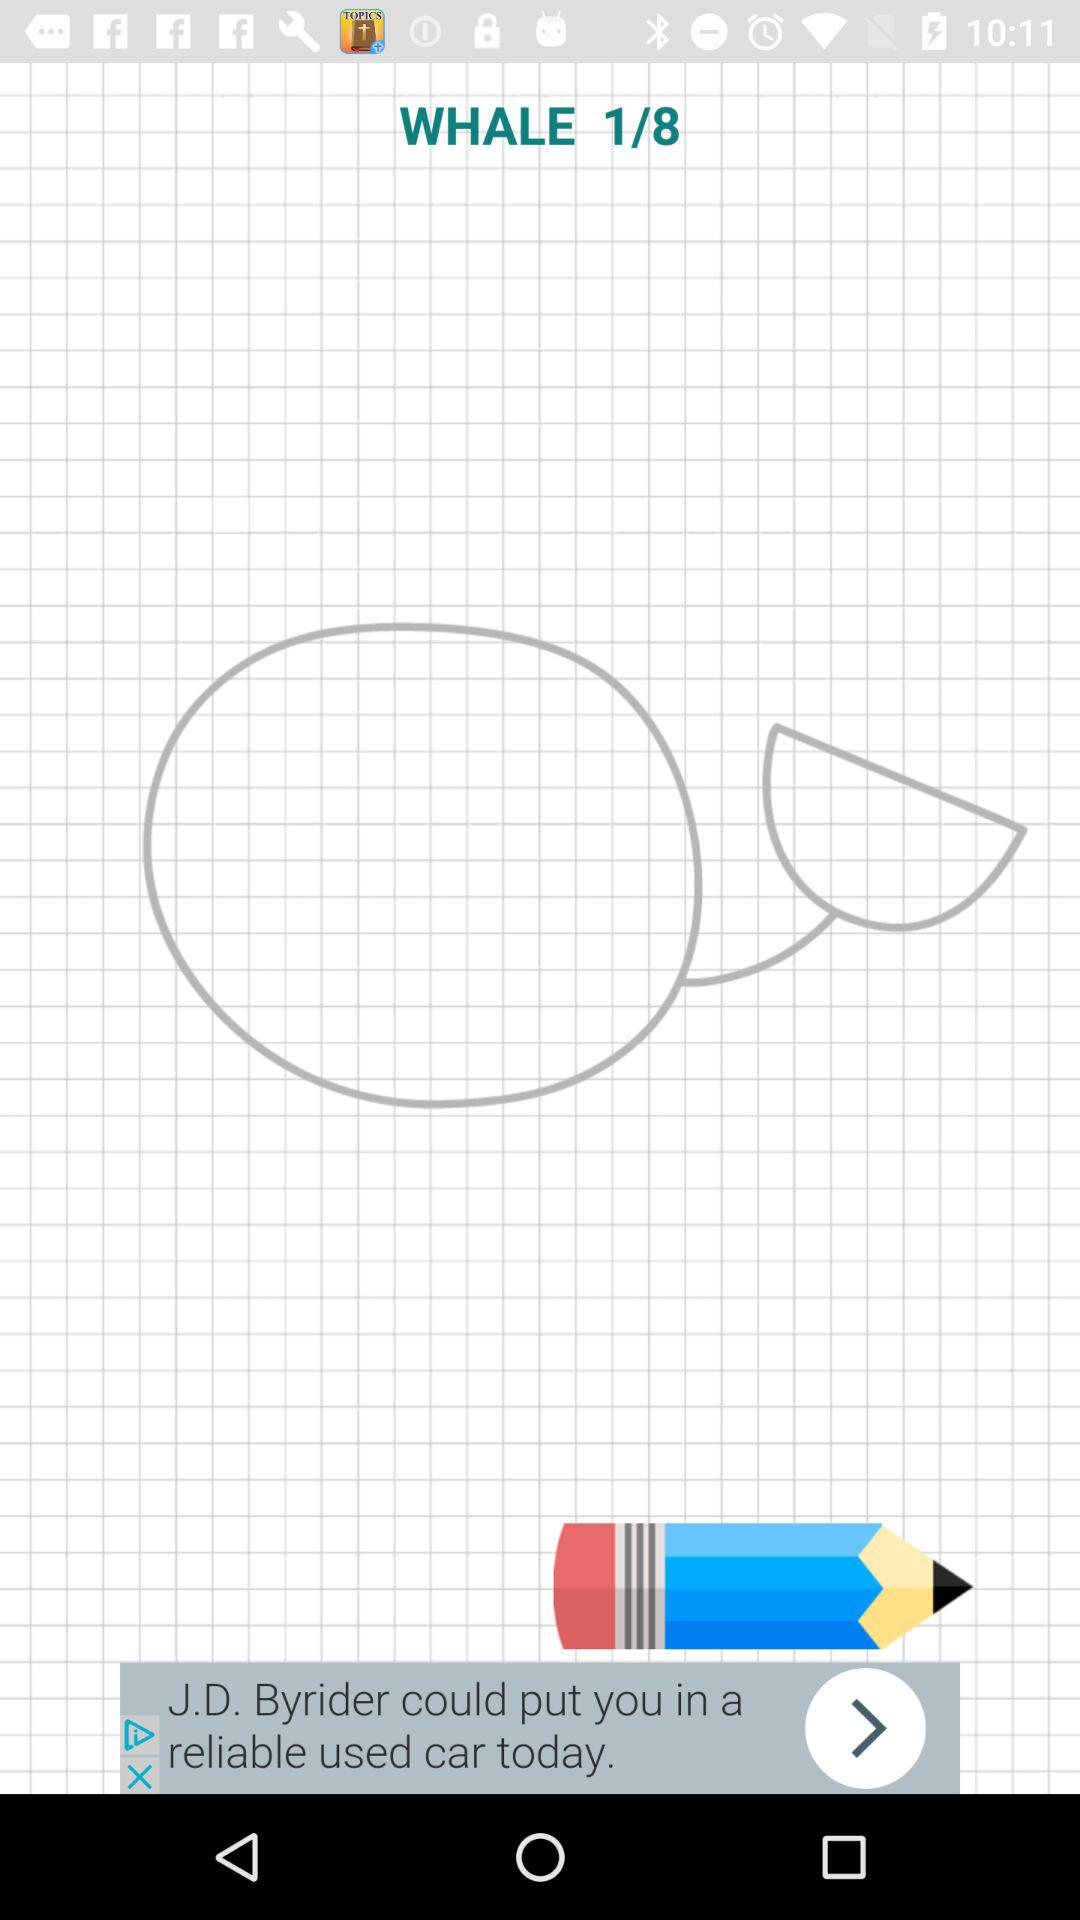What is the number of the current image? The number of the current image is 1. 